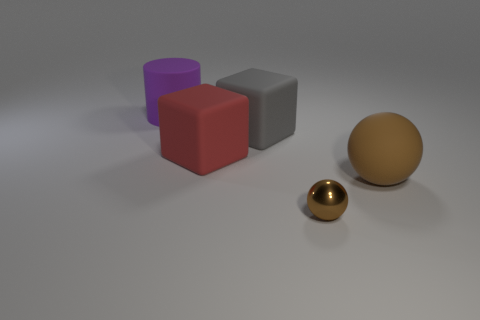Add 3 big purple cylinders. How many objects exist? 8 Subtract all cylinders. How many objects are left? 4 Add 2 matte things. How many matte things are left? 6 Add 2 large brown matte spheres. How many large brown matte spheres exist? 3 Subtract 0 blue cubes. How many objects are left? 5 Subtract all large brown balls. Subtract all brown rubber things. How many objects are left? 3 